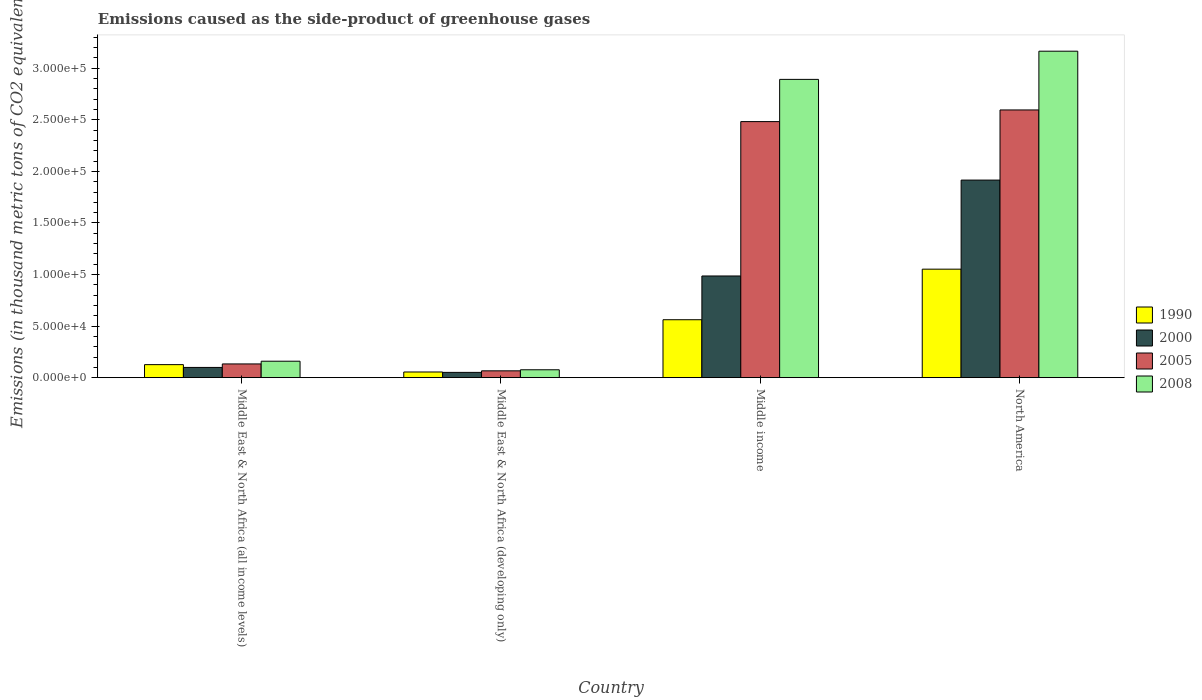How many different coloured bars are there?
Keep it short and to the point. 4. Are the number of bars per tick equal to the number of legend labels?
Your response must be concise. Yes. How many bars are there on the 2nd tick from the right?
Your response must be concise. 4. What is the label of the 1st group of bars from the left?
Ensure brevity in your answer.  Middle East & North Africa (all income levels). What is the emissions caused as the side-product of greenhouse gases in 1990 in Middle East & North Africa (all income levels)?
Make the answer very short. 1.26e+04. Across all countries, what is the maximum emissions caused as the side-product of greenhouse gases in 2005?
Provide a short and direct response. 2.60e+05. Across all countries, what is the minimum emissions caused as the side-product of greenhouse gases in 2008?
Your response must be concise. 7657.2. In which country was the emissions caused as the side-product of greenhouse gases in 2005 maximum?
Your answer should be compact. North America. In which country was the emissions caused as the side-product of greenhouse gases in 2008 minimum?
Provide a succinct answer. Middle East & North Africa (developing only). What is the total emissions caused as the side-product of greenhouse gases in 2008 in the graph?
Provide a succinct answer. 6.29e+05. What is the difference between the emissions caused as the side-product of greenhouse gases in 1990 in Middle income and that in North America?
Provide a short and direct response. -4.90e+04. What is the difference between the emissions caused as the side-product of greenhouse gases in 1990 in North America and the emissions caused as the side-product of greenhouse gases in 2008 in Middle East & North Africa (developing only)?
Provide a succinct answer. 9.75e+04. What is the average emissions caused as the side-product of greenhouse gases in 2005 per country?
Your answer should be very brief. 1.32e+05. What is the difference between the emissions caused as the side-product of greenhouse gases of/in 1990 and emissions caused as the side-product of greenhouse gases of/in 2008 in North America?
Offer a terse response. -2.11e+05. In how many countries, is the emissions caused as the side-product of greenhouse gases in 2005 greater than 220000 thousand metric tons?
Your answer should be compact. 2. What is the ratio of the emissions caused as the side-product of greenhouse gases in 1990 in Middle East & North Africa (developing only) to that in Middle income?
Provide a succinct answer. 0.1. Is the difference between the emissions caused as the side-product of greenhouse gases in 1990 in Middle East & North Africa (all income levels) and Middle East & North Africa (developing only) greater than the difference between the emissions caused as the side-product of greenhouse gases in 2008 in Middle East & North Africa (all income levels) and Middle East & North Africa (developing only)?
Provide a short and direct response. No. What is the difference between the highest and the second highest emissions caused as the side-product of greenhouse gases in 2005?
Provide a succinct answer. -2.46e+05. What is the difference between the highest and the lowest emissions caused as the side-product of greenhouse gases in 1990?
Provide a succinct answer. 9.97e+04. In how many countries, is the emissions caused as the side-product of greenhouse gases in 1990 greater than the average emissions caused as the side-product of greenhouse gases in 1990 taken over all countries?
Give a very brief answer. 2. Is the sum of the emissions caused as the side-product of greenhouse gases in 2000 in Middle East & North Africa (all income levels) and Middle East & North Africa (developing only) greater than the maximum emissions caused as the side-product of greenhouse gases in 1990 across all countries?
Provide a succinct answer. No. How many bars are there?
Ensure brevity in your answer.  16. Are all the bars in the graph horizontal?
Ensure brevity in your answer.  No. How many countries are there in the graph?
Make the answer very short. 4. What is the difference between two consecutive major ticks on the Y-axis?
Your response must be concise. 5.00e+04. Does the graph contain any zero values?
Provide a short and direct response. No. How are the legend labels stacked?
Offer a very short reply. Vertical. What is the title of the graph?
Ensure brevity in your answer.  Emissions caused as the side-product of greenhouse gases. What is the label or title of the Y-axis?
Make the answer very short. Emissions (in thousand metric tons of CO2 equivalent). What is the Emissions (in thousand metric tons of CO2 equivalent) in 1990 in Middle East & North Africa (all income levels)?
Your response must be concise. 1.26e+04. What is the Emissions (in thousand metric tons of CO2 equivalent) in 2000 in Middle East & North Africa (all income levels)?
Offer a terse response. 9923.6. What is the Emissions (in thousand metric tons of CO2 equivalent) of 2005 in Middle East & North Africa (all income levels)?
Ensure brevity in your answer.  1.33e+04. What is the Emissions (in thousand metric tons of CO2 equivalent) of 2008 in Middle East & North Africa (all income levels)?
Provide a succinct answer. 1.60e+04. What is the Emissions (in thousand metric tons of CO2 equivalent) of 1990 in Middle East & North Africa (developing only)?
Your answer should be very brief. 5502.6. What is the Emissions (in thousand metric tons of CO2 equivalent) in 2000 in Middle East & North Africa (developing only)?
Your answer should be compact. 5124.9. What is the Emissions (in thousand metric tons of CO2 equivalent) of 2005 in Middle East & North Africa (developing only)?
Make the answer very short. 6617.8. What is the Emissions (in thousand metric tons of CO2 equivalent) of 2008 in Middle East & North Africa (developing only)?
Make the answer very short. 7657.2. What is the Emissions (in thousand metric tons of CO2 equivalent) of 1990 in Middle income?
Give a very brief answer. 5.62e+04. What is the Emissions (in thousand metric tons of CO2 equivalent) of 2000 in Middle income?
Offer a terse response. 9.86e+04. What is the Emissions (in thousand metric tons of CO2 equivalent) in 2005 in Middle income?
Keep it short and to the point. 2.48e+05. What is the Emissions (in thousand metric tons of CO2 equivalent) in 2008 in Middle income?
Provide a succinct answer. 2.89e+05. What is the Emissions (in thousand metric tons of CO2 equivalent) of 1990 in North America?
Provide a short and direct response. 1.05e+05. What is the Emissions (in thousand metric tons of CO2 equivalent) of 2000 in North America?
Offer a very short reply. 1.92e+05. What is the Emissions (in thousand metric tons of CO2 equivalent) in 2005 in North America?
Your answer should be very brief. 2.60e+05. What is the Emissions (in thousand metric tons of CO2 equivalent) of 2008 in North America?
Your answer should be very brief. 3.17e+05. Across all countries, what is the maximum Emissions (in thousand metric tons of CO2 equivalent) in 1990?
Make the answer very short. 1.05e+05. Across all countries, what is the maximum Emissions (in thousand metric tons of CO2 equivalent) of 2000?
Keep it short and to the point. 1.92e+05. Across all countries, what is the maximum Emissions (in thousand metric tons of CO2 equivalent) of 2005?
Make the answer very short. 2.60e+05. Across all countries, what is the maximum Emissions (in thousand metric tons of CO2 equivalent) of 2008?
Make the answer very short. 3.17e+05. Across all countries, what is the minimum Emissions (in thousand metric tons of CO2 equivalent) of 1990?
Offer a very short reply. 5502.6. Across all countries, what is the minimum Emissions (in thousand metric tons of CO2 equivalent) of 2000?
Keep it short and to the point. 5124.9. Across all countries, what is the minimum Emissions (in thousand metric tons of CO2 equivalent) in 2005?
Your response must be concise. 6617.8. Across all countries, what is the minimum Emissions (in thousand metric tons of CO2 equivalent) in 2008?
Keep it short and to the point. 7657.2. What is the total Emissions (in thousand metric tons of CO2 equivalent) in 1990 in the graph?
Make the answer very short. 1.80e+05. What is the total Emissions (in thousand metric tons of CO2 equivalent) of 2000 in the graph?
Give a very brief answer. 3.05e+05. What is the total Emissions (in thousand metric tons of CO2 equivalent) in 2005 in the graph?
Make the answer very short. 5.28e+05. What is the total Emissions (in thousand metric tons of CO2 equivalent) in 2008 in the graph?
Your answer should be very brief. 6.29e+05. What is the difference between the Emissions (in thousand metric tons of CO2 equivalent) of 1990 in Middle East & North Africa (all income levels) and that in Middle East & North Africa (developing only)?
Give a very brief answer. 7133. What is the difference between the Emissions (in thousand metric tons of CO2 equivalent) of 2000 in Middle East & North Africa (all income levels) and that in Middle East & North Africa (developing only)?
Your answer should be very brief. 4798.7. What is the difference between the Emissions (in thousand metric tons of CO2 equivalent) in 2005 in Middle East & North Africa (all income levels) and that in Middle East & North Africa (developing only)?
Provide a short and direct response. 6694.2. What is the difference between the Emissions (in thousand metric tons of CO2 equivalent) in 2008 in Middle East & North Africa (all income levels) and that in Middle East & North Africa (developing only)?
Your answer should be compact. 8295.8. What is the difference between the Emissions (in thousand metric tons of CO2 equivalent) in 1990 in Middle East & North Africa (all income levels) and that in Middle income?
Offer a terse response. -4.35e+04. What is the difference between the Emissions (in thousand metric tons of CO2 equivalent) in 2000 in Middle East & North Africa (all income levels) and that in Middle income?
Your response must be concise. -8.87e+04. What is the difference between the Emissions (in thousand metric tons of CO2 equivalent) in 2005 in Middle East & North Africa (all income levels) and that in Middle income?
Your answer should be very brief. -2.35e+05. What is the difference between the Emissions (in thousand metric tons of CO2 equivalent) in 2008 in Middle East & North Africa (all income levels) and that in Middle income?
Your answer should be very brief. -2.73e+05. What is the difference between the Emissions (in thousand metric tons of CO2 equivalent) of 1990 in Middle East & North Africa (all income levels) and that in North America?
Your answer should be very brief. -9.26e+04. What is the difference between the Emissions (in thousand metric tons of CO2 equivalent) of 2000 in Middle East & North Africa (all income levels) and that in North America?
Make the answer very short. -1.82e+05. What is the difference between the Emissions (in thousand metric tons of CO2 equivalent) in 2005 in Middle East & North Africa (all income levels) and that in North America?
Your response must be concise. -2.46e+05. What is the difference between the Emissions (in thousand metric tons of CO2 equivalent) in 2008 in Middle East & North Africa (all income levels) and that in North America?
Keep it short and to the point. -3.01e+05. What is the difference between the Emissions (in thousand metric tons of CO2 equivalent) of 1990 in Middle East & North Africa (developing only) and that in Middle income?
Offer a very short reply. -5.07e+04. What is the difference between the Emissions (in thousand metric tons of CO2 equivalent) in 2000 in Middle East & North Africa (developing only) and that in Middle income?
Your response must be concise. -9.35e+04. What is the difference between the Emissions (in thousand metric tons of CO2 equivalent) in 2005 in Middle East & North Africa (developing only) and that in Middle income?
Give a very brief answer. -2.42e+05. What is the difference between the Emissions (in thousand metric tons of CO2 equivalent) of 2008 in Middle East & North Africa (developing only) and that in Middle income?
Your answer should be compact. -2.82e+05. What is the difference between the Emissions (in thousand metric tons of CO2 equivalent) in 1990 in Middle East & North Africa (developing only) and that in North America?
Provide a succinct answer. -9.97e+04. What is the difference between the Emissions (in thousand metric tons of CO2 equivalent) in 2000 in Middle East & North Africa (developing only) and that in North America?
Provide a succinct answer. -1.86e+05. What is the difference between the Emissions (in thousand metric tons of CO2 equivalent) in 2005 in Middle East & North Africa (developing only) and that in North America?
Give a very brief answer. -2.53e+05. What is the difference between the Emissions (in thousand metric tons of CO2 equivalent) in 2008 in Middle East & North Africa (developing only) and that in North America?
Offer a terse response. -3.09e+05. What is the difference between the Emissions (in thousand metric tons of CO2 equivalent) of 1990 in Middle income and that in North America?
Your answer should be compact. -4.90e+04. What is the difference between the Emissions (in thousand metric tons of CO2 equivalent) in 2000 in Middle income and that in North America?
Give a very brief answer. -9.30e+04. What is the difference between the Emissions (in thousand metric tons of CO2 equivalent) of 2005 in Middle income and that in North America?
Your response must be concise. -1.13e+04. What is the difference between the Emissions (in thousand metric tons of CO2 equivalent) of 2008 in Middle income and that in North America?
Offer a terse response. -2.73e+04. What is the difference between the Emissions (in thousand metric tons of CO2 equivalent) in 1990 in Middle East & North Africa (all income levels) and the Emissions (in thousand metric tons of CO2 equivalent) in 2000 in Middle East & North Africa (developing only)?
Make the answer very short. 7510.7. What is the difference between the Emissions (in thousand metric tons of CO2 equivalent) of 1990 in Middle East & North Africa (all income levels) and the Emissions (in thousand metric tons of CO2 equivalent) of 2005 in Middle East & North Africa (developing only)?
Your answer should be compact. 6017.8. What is the difference between the Emissions (in thousand metric tons of CO2 equivalent) in 1990 in Middle East & North Africa (all income levels) and the Emissions (in thousand metric tons of CO2 equivalent) in 2008 in Middle East & North Africa (developing only)?
Your answer should be very brief. 4978.4. What is the difference between the Emissions (in thousand metric tons of CO2 equivalent) of 2000 in Middle East & North Africa (all income levels) and the Emissions (in thousand metric tons of CO2 equivalent) of 2005 in Middle East & North Africa (developing only)?
Give a very brief answer. 3305.8. What is the difference between the Emissions (in thousand metric tons of CO2 equivalent) of 2000 in Middle East & North Africa (all income levels) and the Emissions (in thousand metric tons of CO2 equivalent) of 2008 in Middle East & North Africa (developing only)?
Make the answer very short. 2266.4. What is the difference between the Emissions (in thousand metric tons of CO2 equivalent) in 2005 in Middle East & North Africa (all income levels) and the Emissions (in thousand metric tons of CO2 equivalent) in 2008 in Middle East & North Africa (developing only)?
Provide a succinct answer. 5654.8. What is the difference between the Emissions (in thousand metric tons of CO2 equivalent) of 1990 in Middle East & North Africa (all income levels) and the Emissions (in thousand metric tons of CO2 equivalent) of 2000 in Middle income?
Provide a succinct answer. -8.60e+04. What is the difference between the Emissions (in thousand metric tons of CO2 equivalent) in 1990 in Middle East & North Africa (all income levels) and the Emissions (in thousand metric tons of CO2 equivalent) in 2005 in Middle income?
Provide a succinct answer. -2.36e+05. What is the difference between the Emissions (in thousand metric tons of CO2 equivalent) in 1990 in Middle East & North Africa (all income levels) and the Emissions (in thousand metric tons of CO2 equivalent) in 2008 in Middle income?
Offer a very short reply. -2.77e+05. What is the difference between the Emissions (in thousand metric tons of CO2 equivalent) of 2000 in Middle East & North Africa (all income levels) and the Emissions (in thousand metric tons of CO2 equivalent) of 2005 in Middle income?
Keep it short and to the point. -2.38e+05. What is the difference between the Emissions (in thousand metric tons of CO2 equivalent) of 2000 in Middle East & North Africa (all income levels) and the Emissions (in thousand metric tons of CO2 equivalent) of 2008 in Middle income?
Make the answer very short. -2.79e+05. What is the difference between the Emissions (in thousand metric tons of CO2 equivalent) in 2005 in Middle East & North Africa (all income levels) and the Emissions (in thousand metric tons of CO2 equivalent) in 2008 in Middle income?
Provide a succinct answer. -2.76e+05. What is the difference between the Emissions (in thousand metric tons of CO2 equivalent) of 1990 in Middle East & North Africa (all income levels) and the Emissions (in thousand metric tons of CO2 equivalent) of 2000 in North America?
Give a very brief answer. -1.79e+05. What is the difference between the Emissions (in thousand metric tons of CO2 equivalent) in 1990 in Middle East & North Africa (all income levels) and the Emissions (in thousand metric tons of CO2 equivalent) in 2005 in North America?
Ensure brevity in your answer.  -2.47e+05. What is the difference between the Emissions (in thousand metric tons of CO2 equivalent) of 1990 in Middle East & North Africa (all income levels) and the Emissions (in thousand metric tons of CO2 equivalent) of 2008 in North America?
Keep it short and to the point. -3.04e+05. What is the difference between the Emissions (in thousand metric tons of CO2 equivalent) in 2000 in Middle East & North Africa (all income levels) and the Emissions (in thousand metric tons of CO2 equivalent) in 2005 in North America?
Your answer should be very brief. -2.50e+05. What is the difference between the Emissions (in thousand metric tons of CO2 equivalent) in 2000 in Middle East & North Africa (all income levels) and the Emissions (in thousand metric tons of CO2 equivalent) in 2008 in North America?
Offer a very short reply. -3.07e+05. What is the difference between the Emissions (in thousand metric tons of CO2 equivalent) of 2005 in Middle East & North Africa (all income levels) and the Emissions (in thousand metric tons of CO2 equivalent) of 2008 in North America?
Give a very brief answer. -3.03e+05. What is the difference between the Emissions (in thousand metric tons of CO2 equivalent) in 1990 in Middle East & North Africa (developing only) and the Emissions (in thousand metric tons of CO2 equivalent) in 2000 in Middle income?
Your response must be concise. -9.31e+04. What is the difference between the Emissions (in thousand metric tons of CO2 equivalent) in 1990 in Middle East & North Africa (developing only) and the Emissions (in thousand metric tons of CO2 equivalent) in 2005 in Middle income?
Ensure brevity in your answer.  -2.43e+05. What is the difference between the Emissions (in thousand metric tons of CO2 equivalent) of 1990 in Middle East & North Africa (developing only) and the Emissions (in thousand metric tons of CO2 equivalent) of 2008 in Middle income?
Provide a short and direct response. -2.84e+05. What is the difference between the Emissions (in thousand metric tons of CO2 equivalent) of 2000 in Middle East & North Africa (developing only) and the Emissions (in thousand metric tons of CO2 equivalent) of 2005 in Middle income?
Provide a short and direct response. -2.43e+05. What is the difference between the Emissions (in thousand metric tons of CO2 equivalent) in 2000 in Middle East & North Africa (developing only) and the Emissions (in thousand metric tons of CO2 equivalent) in 2008 in Middle income?
Your response must be concise. -2.84e+05. What is the difference between the Emissions (in thousand metric tons of CO2 equivalent) in 2005 in Middle East & North Africa (developing only) and the Emissions (in thousand metric tons of CO2 equivalent) in 2008 in Middle income?
Your response must be concise. -2.83e+05. What is the difference between the Emissions (in thousand metric tons of CO2 equivalent) of 1990 in Middle East & North Africa (developing only) and the Emissions (in thousand metric tons of CO2 equivalent) of 2000 in North America?
Offer a terse response. -1.86e+05. What is the difference between the Emissions (in thousand metric tons of CO2 equivalent) of 1990 in Middle East & North Africa (developing only) and the Emissions (in thousand metric tons of CO2 equivalent) of 2005 in North America?
Offer a terse response. -2.54e+05. What is the difference between the Emissions (in thousand metric tons of CO2 equivalent) of 1990 in Middle East & North Africa (developing only) and the Emissions (in thousand metric tons of CO2 equivalent) of 2008 in North America?
Give a very brief answer. -3.11e+05. What is the difference between the Emissions (in thousand metric tons of CO2 equivalent) of 2000 in Middle East & North Africa (developing only) and the Emissions (in thousand metric tons of CO2 equivalent) of 2005 in North America?
Your answer should be very brief. -2.54e+05. What is the difference between the Emissions (in thousand metric tons of CO2 equivalent) of 2000 in Middle East & North Africa (developing only) and the Emissions (in thousand metric tons of CO2 equivalent) of 2008 in North America?
Ensure brevity in your answer.  -3.11e+05. What is the difference between the Emissions (in thousand metric tons of CO2 equivalent) in 2005 in Middle East & North Africa (developing only) and the Emissions (in thousand metric tons of CO2 equivalent) in 2008 in North America?
Provide a short and direct response. -3.10e+05. What is the difference between the Emissions (in thousand metric tons of CO2 equivalent) in 1990 in Middle income and the Emissions (in thousand metric tons of CO2 equivalent) in 2000 in North America?
Provide a succinct answer. -1.35e+05. What is the difference between the Emissions (in thousand metric tons of CO2 equivalent) of 1990 in Middle income and the Emissions (in thousand metric tons of CO2 equivalent) of 2005 in North America?
Offer a very short reply. -2.03e+05. What is the difference between the Emissions (in thousand metric tons of CO2 equivalent) in 1990 in Middle income and the Emissions (in thousand metric tons of CO2 equivalent) in 2008 in North America?
Offer a very short reply. -2.60e+05. What is the difference between the Emissions (in thousand metric tons of CO2 equivalent) of 2000 in Middle income and the Emissions (in thousand metric tons of CO2 equivalent) of 2005 in North America?
Offer a terse response. -1.61e+05. What is the difference between the Emissions (in thousand metric tons of CO2 equivalent) in 2000 in Middle income and the Emissions (in thousand metric tons of CO2 equivalent) in 2008 in North America?
Your answer should be very brief. -2.18e+05. What is the difference between the Emissions (in thousand metric tons of CO2 equivalent) of 2005 in Middle income and the Emissions (in thousand metric tons of CO2 equivalent) of 2008 in North America?
Offer a terse response. -6.83e+04. What is the average Emissions (in thousand metric tons of CO2 equivalent) in 1990 per country?
Offer a very short reply. 4.49e+04. What is the average Emissions (in thousand metric tons of CO2 equivalent) of 2000 per country?
Keep it short and to the point. 7.63e+04. What is the average Emissions (in thousand metric tons of CO2 equivalent) of 2005 per country?
Provide a succinct answer. 1.32e+05. What is the average Emissions (in thousand metric tons of CO2 equivalent) of 2008 per country?
Your response must be concise. 1.57e+05. What is the difference between the Emissions (in thousand metric tons of CO2 equivalent) of 1990 and Emissions (in thousand metric tons of CO2 equivalent) of 2000 in Middle East & North Africa (all income levels)?
Ensure brevity in your answer.  2712. What is the difference between the Emissions (in thousand metric tons of CO2 equivalent) in 1990 and Emissions (in thousand metric tons of CO2 equivalent) in 2005 in Middle East & North Africa (all income levels)?
Your answer should be compact. -676.4. What is the difference between the Emissions (in thousand metric tons of CO2 equivalent) in 1990 and Emissions (in thousand metric tons of CO2 equivalent) in 2008 in Middle East & North Africa (all income levels)?
Give a very brief answer. -3317.4. What is the difference between the Emissions (in thousand metric tons of CO2 equivalent) in 2000 and Emissions (in thousand metric tons of CO2 equivalent) in 2005 in Middle East & North Africa (all income levels)?
Your answer should be compact. -3388.4. What is the difference between the Emissions (in thousand metric tons of CO2 equivalent) of 2000 and Emissions (in thousand metric tons of CO2 equivalent) of 2008 in Middle East & North Africa (all income levels)?
Give a very brief answer. -6029.4. What is the difference between the Emissions (in thousand metric tons of CO2 equivalent) in 2005 and Emissions (in thousand metric tons of CO2 equivalent) in 2008 in Middle East & North Africa (all income levels)?
Your answer should be very brief. -2641. What is the difference between the Emissions (in thousand metric tons of CO2 equivalent) in 1990 and Emissions (in thousand metric tons of CO2 equivalent) in 2000 in Middle East & North Africa (developing only)?
Keep it short and to the point. 377.7. What is the difference between the Emissions (in thousand metric tons of CO2 equivalent) in 1990 and Emissions (in thousand metric tons of CO2 equivalent) in 2005 in Middle East & North Africa (developing only)?
Provide a succinct answer. -1115.2. What is the difference between the Emissions (in thousand metric tons of CO2 equivalent) of 1990 and Emissions (in thousand metric tons of CO2 equivalent) of 2008 in Middle East & North Africa (developing only)?
Ensure brevity in your answer.  -2154.6. What is the difference between the Emissions (in thousand metric tons of CO2 equivalent) in 2000 and Emissions (in thousand metric tons of CO2 equivalent) in 2005 in Middle East & North Africa (developing only)?
Offer a terse response. -1492.9. What is the difference between the Emissions (in thousand metric tons of CO2 equivalent) of 2000 and Emissions (in thousand metric tons of CO2 equivalent) of 2008 in Middle East & North Africa (developing only)?
Ensure brevity in your answer.  -2532.3. What is the difference between the Emissions (in thousand metric tons of CO2 equivalent) of 2005 and Emissions (in thousand metric tons of CO2 equivalent) of 2008 in Middle East & North Africa (developing only)?
Keep it short and to the point. -1039.4. What is the difference between the Emissions (in thousand metric tons of CO2 equivalent) of 1990 and Emissions (in thousand metric tons of CO2 equivalent) of 2000 in Middle income?
Offer a very short reply. -4.24e+04. What is the difference between the Emissions (in thousand metric tons of CO2 equivalent) of 1990 and Emissions (in thousand metric tons of CO2 equivalent) of 2005 in Middle income?
Give a very brief answer. -1.92e+05. What is the difference between the Emissions (in thousand metric tons of CO2 equivalent) in 1990 and Emissions (in thousand metric tons of CO2 equivalent) in 2008 in Middle income?
Keep it short and to the point. -2.33e+05. What is the difference between the Emissions (in thousand metric tons of CO2 equivalent) in 2000 and Emissions (in thousand metric tons of CO2 equivalent) in 2005 in Middle income?
Your response must be concise. -1.50e+05. What is the difference between the Emissions (in thousand metric tons of CO2 equivalent) in 2000 and Emissions (in thousand metric tons of CO2 equivalent) in 2008 in Middle income?
Ensure brevity in your answer.  -1.91e+05. What is the difference between the Emissions (in thousand metric tons of CO2 equivalent) in 2005 and Emissions (in thousand metric tons of CO2 equivalent) in 2008 in Middle income?
Offer a terse response. -4.09e+04. What is the difference between the Emissions (in thousand metric tons of CO2 equivalent) in 1990 and Emissions (in thousand metric tons of CO2 equivalent) in 2000 in North America?
Give a very brief answer. -8.64e+04. What is the difference between the Emissions (in thousand metric tons of CO2 equivalent) in 1990 and Emissions (in thousand metric tons of CO2 equivalent) in 2005 in North America?
Give a very brief answer. -1.54e+05. What is the difference between the Emissions (in thousand metric tons of CO2 equivalent) of 1990 and Emissions (in thousand metric tons of CO2 equivalent) of 2008 in North America?
Provide a short and direct response. -2.11e+05. What is the difference between the Emissions (in thousand metric tons of CO2 equivalent) in 2000 and Emissions (in thousand metric tons of CO2 equivalent) in 2005 in North America?
Offer a terse response. -6.80e+04. What is the difference between the Emissions (in thousand metric tons of CO2 equivalent) in 2000 and Emissions (in thousand metric tons of CO2 equivalent) in 2008 in North America?
Make the answer very short. -1.25e+05. What is the difference between the Emissions (in thousand metric tons of CO2 equivalent) in 2005 and Emissions (in thousand metric tons of CO2 equivalent) in 2008 in North America?
Your response must be concise. -5.70e+04. What is the ratio of the Emissions (in thousand metric tons of CO2 equivalent) in 1990 in Middle East & North Africa (all income levels) to that in Middle East & North Africa (developing only)?
Provide a succinct answer. 2.3. What is the ratio of the Emissions (in thousand metric tons of CO2 equivalent) in 2000 in Middle East & North Africa (all income levels) to that in Middle East & North Africa (developing only)?
Your answer should be compact. 1.94. What is the ratio of the Emissions (in thousand metric tons of CO2 equivalent) of 2005 in Middle East & North Africa (all income levels) to that in Middle East & North Africa (developing only)?
Provide a short and direct response. 2.01. What is the ratio of the Emissions (in thousand metric tons of CO2 equivalent) in 2008 in Middle East & North Africa (all income levels) to that in Middle East & North Africa (developing only)?
Offer a terse response. 2.08. What is the ratio of the Emissions (in thousand metric tons of CO2 equivalent) of 1990 in Middle East & North Africa (all income levels) to that in Middle income?
Keep it short and to the point. 0.22. What is the ratio of the Emissions (in thousand metric tons of CO2 equivalent) in 2000 in Middle East & North Africa (all income levels) to that in Middle income?
Keep it short and to the point. 0.1. What is the ratio of the Emissions (in thousand metric tons of CO2 equivalent) in 2005 in Middle East & North Africa (all income levels) to that in Middle income?
Your answer should be compact. 0.05. What is the ratio of the Emissions (in thousand metric tons of CO2 equivalent) in 2008 in Middle East & North Africa (all income levels) to that in Middle income?
Make the answer very short. 0.06. What is the ratio of the Emissions (in thousand metric tons of CO2 equivalent) in 1990 in Middle East & North Africa (all income levels) to that in North America?
Ensure brevity in your answer.  0.12. What is the ratio of the Emissions (in thousand metric tons of CO2 equivalent) of 2000 in Middle East & North Africa (all income levels) to that in North America?
Your answer should be compact. 0.05. What is the ratio of the Emissions (in thousand metric tons of CO2 equivalent) in 2005 in Middle East & North Africa (all income levels) to that in North America?
Give a very brief answer. 0.05. What is the ratio of the Emissions (in thousand metric tons of CO2 equivalent) of 2008 in Middle East & North Africa (all income levels) to that in North America?
Keep it short and to the point. 0.05. What is the ratio of the Emissions (in thousand metric tons of CO2 equivalent) of 1990 in Middle East & North Africa (developing only) to that in Middle income?
Give a very brief answer. 0.1. What is the ratio of the Emissions (in thousand metric tons of CO2 equivalent) of 2000 in Middle East & North Africa (developing only) to that in Middle income?
Ensure brevity in your answer.  0.05. What is the ratio of the Emissions (in thousand metric tons of CO2 equivalent) in 2005 in Middle East & North Africa (developing only) to that in Middle income?
Give a very brief answer. 0.03. What is the ratio of the Emissions (in thousand metric tons of CO2 equivalent) in 2008 in Middle East & North Africa (developing only) to that in Middle income?
Make the answer very short. 0.03. What is the ratio of the Emissions (in thousand metric tons of CO2 equivalent) of 1990 in Middle East & North Africa (developing only) to that in North America?
Keep it short and to the point. 0.05. What is the ratio of the Emissions (in thousand metric tons of CO2 equivalent) of 2000 in Middle East & North Africa (developing only) to that in North America?
Your response must be concise. 0.03. What is the ratio of the Emissions (in thousand metric tons of CO2 equivalent) in 2005 in Middle East & North Africa (developing only) to that in North America?
Your response must be concise. 0.03. What is the ratio of the Emissions (in thousand metric tons of CO2 equivalent) of 2008 in Middle East & North Africa (developing only) to that in North America?
Make the answer very short. 0.02. What is the ratio of the Emissions (in thousand metric tons of CO2 equivalent) in 1990 in Middle income to that in North America?
Your response must be concise. 0.53. What is the ratio of the Emissions (in thousand metric tons of CO2 equivalent) in 2000 in Middle income to that in North America?
Ensure brevity in your answer.  0.51. What is the ratio of the Emissions (in thousand metric tons of CO2 equivalent) of 2005 in Middle income to that in North America?
Offer a terse response. 0.96. What is the ratio of the Emissions (in thousand metric tons of CO2 equivalent) of 2008 in Middle income to that in North America?
Provide a short and direct response. 0.91. What is the difference between the highest and the second highest Emissions (in thousand metric tons of CO2 equivalent) in 1990?
Your response must be concise. 4.90e+04. What is the difference between the highest and the second highest Emissions (in thousand metric tons of CO2 equivalent) in 2000?
Give a very brief answer. 9.30e+04. What is the difference between the highest and the second highest Emissions (in thousand metric tons of CO2 equivalent) in 2005?
Offer a terse response. 1.13e+04. What is the difference between the highest and the second highest Emissions (in thousand metric tons of CO2 equivalent) in 2008?
Give a very brief answer. 2.73e+04. What is the difference between the highest and the lowest Emissions (in thousand metric tons of CO2 equivalent) of 1990?
Ensure brevity in your answer.  9.97e+04. What is the difference between the highest and the lowest Emissions (in thousand metric tons of CO2 equivalent) in 2000?
Your response must be concise. 1.86e+05. What is the difference between the highest and the lowest Emissions (in thousand metric tons of CO2 equivalent) in 2005?
Offer a very short reply. 2.53e+05. What is the difference between the highest and the lowest Emissions (in thousand metric tons of CO2 equivalent) in 2008?
Offer a very short reply. 3.09e+05. 